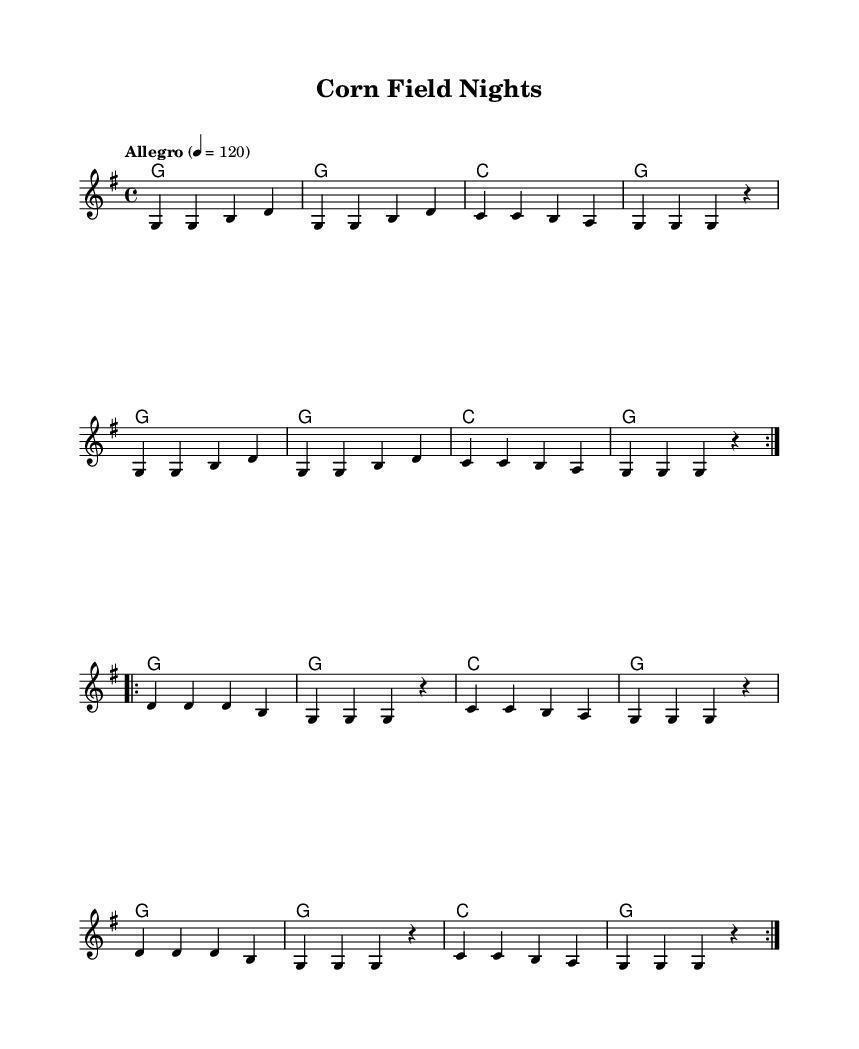What is the key signature of this music? The key signature is G major, which has one sharp (F#). This is indicated at the beginning of the staff before the first measure.
Answer: G major What is the time signature of this music? The time signature is 4/4, which signifies four beats per measure. This is shown at the beginning of the staff.
Answer: 4/4 What is the tempo marking of this music? The tempo marking is "Allegro" with a metronome marking of 120, indicating a fast pace. This is noted at the beginning of the score.
Answer: Allegro How many times is the verse repeated? The verse is repeated twice as indicated by the "repeat volta 2" marking in the melody section. This means the section will play through two times before moving on.
Answer: 2 What is the theme of the lyrics in the chorus? The lyrics in the chorus celebrate Midwestern life and express a sense of pride and community. Phrases like "Midwest life, it's better than it seems" emphasize this sentiment.
Answer: Pride What is the highest note in the melody? The highest note in the melody is D, which appears in the second measure of the first section before returning to G. This can be determined by analyzing the pitch of the notes in the melody line.
Answer: D What do the lyrics mention about Friday nights? The lyrics mention "Friday night lights," which refers to the excitement of evening activities in small towns, commonly associated with high school sports. This establishes a vivid image of small-town life.
Answer: Excitement 